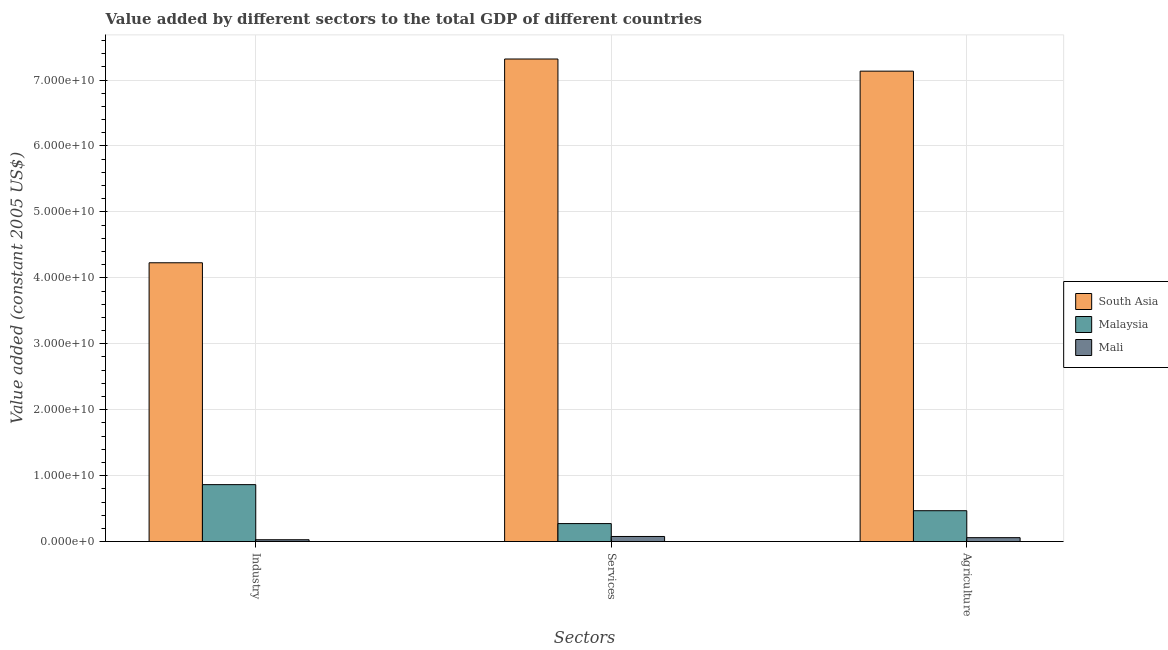How many groups of bars are there?
Your answer should be compact. 3. Are the number of bars per tick equal to the number of legend labels?
Give a very brief answer. Yes. How many bars are there on the 1st tick from the left?
Make the answer very short. 3. How many bars are there on the 1st tick from the right?
Your answer should be compact. 3. What is the label of the 1st group of bars from the left?
Make the answer very short. Industry. What is the value added by agricultural sector in Malaysia?
Offer a very short reply. 4.68e+09. Across all countries, what is the maximum value added by agricultural sector?
Ensure brevity in your answer.  7.13e+1. Across all countries, what is the minimum value added by industrial sector?
Your answer should be very brief. 2.76e+08. In which country was the value added by industrial sector minimum?
Keep it short and to the point. Mali. What is the total value added by services in the graph?
Keep it short and to the point. 7.67e+1. What is the difference between the value added by industrial sector in Mali and that in Malaysia?
Ensure brevity in your answer.  -8.36e+09. What is the difference between the value added by agricultural sector in South Asia and the value added by services in Malaysia?
Offer a terse response. 6.86e+1. What is the average value added by agricultural sector per country?
Give a very brief answer. 2.55e+1. What is the difference between the value added by services and value added by industrial sector in Mali?
Keep it short and to the point. 4.95e+08. In how many countries, is the value added by services greater than 34000000000 US$?
Provide a short and direct response. 1. What is the ratio of the value added by agricultural sector in Mali to that in South Asia?
Make the answer very short. 0.01. Is the value added by industrial sector in Mali less than that in Malaysia?
Your answer should be compact. Yes. What is the difference between the highest and the second highest value added by industrial sector?
Provide a succinct answer. 3.36e+1. What is the difference between the highest and the lowest value added by agricultural sector?
Offer a terse response. 7.08e+1. Is the sum of the value added by services in South Asia and Malaysia greater than the maximum value added by agricultural sector across all countries?
Make the answer very short. Yes. What does the 1st bar from the left in Services represents?
Your answer should be compact. South Asia. Is it the case that in every country, the sum of the value added by industrial sector and value added by services is greater than the value added by agricultural sector?
Provide a short and direct response. Yes. How many bars are there?
Ensure brevity in your answer.  9. Are the values on the major ticks of Y-axis written in scientific E-notation?
Your answer should be compact. Yes. Does the graph contain any zero values?
Give a very brief answer. No. How are the legend labels stacked?
Ensure brevity in your answer.  Vertical. What is the title of the graph?
Keep it short and to the point. Value added by different sectors to the total GDP of different countries. Does "Croatia" appear as one of the legend labels in the graph?
Your answer should be compact. No. What is the label or title of the X-axis?
Your answer should be compact. Sectors. What is the label or title of the Y-axis?
Provide a short and direct response. Value added (constant 2005 US$). What is the Value added (constant 2005 US$) in South Asia in Industry?
Offer a terse response. 4.23e+1. What is the Value added (constant 2005 US$) in Malaysia in Industry?
Offer a terse response. 8.63e+09. What is the Value added (constant 2005 US$) in Mali in Industry?
Your answer should be very brief. 2.76e+08. What is the Value added (constant 2005 US$) in South Asia in Services?
Offer a terse response. 7.32e+1. What is the Value added (constant 2005 US$) of Malaysia in Services?
Make the answer very short. 2.73e+09. What is the Value added (constant 2005 US$) in Mali in Services?
Provide a succinct answer. 7.71e+08. What is the Value added (constant 2005 US$) of South Asia in Agriculture?
Provide a succinct answer. 7.13e+1. What is the Value added (constant 2005 US$) in Malaysia in Agriculture?
Ensure brevity in your answer.  4.68e+09. What is the Value added (constant 2005 US$) of Mali in Agriculture?
Ensure brevity in your answer.  5.90e+08. Across all Sectors, what is the maximum Value added (constant 2005 US$) in South Asia?
Make the answer very short. 7.32e+1. Across all Sectors, what is the maximum Value added (constant 2005 US$) in Malaysia?
Ensure brevity in your answer.  8.63e+09. Across all Sectors, what is the maximum Value added (constant 2005 US$) in Mali?
Keep it short and to the point. 7.71e+08. Across all Sectors, what is the minimum Value added (constant 2005 US$) of South Asia?
Your answer should be very brief. 4.23e+1. Across all Sectors, what is the minimum Value added (constant 2005 US$) of Malaysia?
Your answer should be compact. 2.73e+09. Across all Sectors, what is the minimum Value added (constant 2005 US$) in Mali?
Your answer should be compact. 2.76e+08. What is the total Value added (constant 2005 US$) in South Asia in the graph?
Offer a terse response. 1.87e+11. What is the total Value added (constant 2005 US$) of Malaysia in the graph?
Your response must be concise. 1.60e+1. What is the total Value added (constant 2005 US$) in Mali in the graph?
Offer a very short reply. 1.64e+09. What is the difference between the Value added (constant 2005 US$) in South Asia in Industry and that in Services?
Ensure brevity in your answer.  -3.09e+1. What is the difference between the Value added (constant 2005 US$) in Malaysia in Industry and that in Services?
Ensure brevity in your answer.  5.91e+09. What is the difference between the Value added (constant 2005 US$) of Mali in Industry and that in Services?
Keep it short and to the point. -4.95e+08. What is the difference between the Value added (constant 2005 US$) of South Asia in Industry and that in Agriculture?
Provide a short and direct response. -2.91e+1. What is the difference between the Value added (constant 2005 US$) in Malaysia in Industry and that in Agriculture?
Make the answer very short. 3.96e+09. What is the difference between the Value added (constant 2005 US$) of Mali in Industry and that in Agriculture?
Offer a very short reply. -3.15e+08. What is the difference between the Value added (constant 2005 US$) in South Asia in Services and that in Agriculture?
Offer a terse response. 1.84e+09. What is the difference between the Value added (constant 2005 US$) of Malaysia in Services and that in Agriculture?
Ensure brevity in your answer.  -1.95e+09. What is the difference between the Value added (constant 2005 US$) of Mali in Services and that in Agriculture?
Give a very brief answer. 1.80e+08. What is the difference between the Value added (constant 2005 US$) of South Asia in Industry and the Value added (constant 2005 US$) of Malaysia in Services?
Your response must be concise. 3.96e+1. What is the difference between the Value added (constant 2005 US$) in South Asia in Industry and the Value added (constant 2005 US$) in Mali in Services?
Your answer should be compact. 4.15e+1. What is the difference between the Value added (constant 2005 US$) of Malaysia in Industry and the Value added (constant 2005 US$) of Mali in Services?
Make the answer very short. 7.86e+09. What is the difference between the Value added (constant 2005 US$) of South Asia in Industry and the Value added (constant 2005 US$) of Malaysia in Agriculture?
Provide a short and direct response. 3.76e+1. What is the difference between the Value added (constant 2005 US$) of South Asia in Industry and the Value added (constant 2005 US$) of Mali in Agriculture?
Your answer should be very brief. 4.17e+1. What is the difference between the Value added (constant 2005 US$) in Malaysia in Industry and the Value added (constant 2005 US$) in Mali in Agriculture?
Ensure brevity in your answer.  8.04e+09. What is the difference between the Value added (constant 2005 US$) in South Asia in Services and the Value added (constant 2005 US$) in Malaysia in Agriculture?
Keep it short and to the point. 6.85e+1. What is the difference between the Value added (constant 2005 US$) in South Asia in Services and the Value added (constant 2005 US$) in Mali in Agriculture?
Provide a succinct answer. 7.26e+1. What is the difference between the Value added (constant 2005 US$) in Malaysia in Services and the Value added (constant 2005 US$) in Mali in Agriculture?
Your response must be concise. 2.14e+09. What is the average Value added (constant 2005 US$) in South Asia per Sectors?
Make the answer very short. 6.23e+1. What is the average Value added (constant 2005 US$) of Malaysia per Sectors?
Provide a short and direct response. 5.35e+09. What is the average Value added (constant 2005 US$) in Mali per Sectors?
Ensure brevity in your answer.  5.46e+08. What is the difference between the Value added (constant 2005 US$) of South Asia and Value added (constant 2005 US$) of Malaysia in Industry?
Ensure brevity in your answer.  3.36e+1. What is the difference between the Value added (constant 2005 US$) in South Asia and Value added (constant 2005 US$) in Mali in Industry?
Keep it short and to the point. 4.20e+1. What is the difference between the Value added (constant 2005 US$) of Malaysia and Value added (constant 2005 US$) of Mali in Industry?
Provide a short and direct response. 8.36e+09. What is the difference between the Value added (constant 2005 US$) in South Asia and Value added (constant 2005 US$) in Malaysia in Services?
Provide a succinct answer. 7.05e+1. What is the difference between the Value added (constant 2005 US$) in South Asia and Value added (constant 2005 US$) in Mali in Services?
Give a very brief answer. 7.24e+1. What is the difference between the Value added (constant 2005 US$) in Malaysia and Value added (constant 2005 US$) in Mali in Services?
Provide a short and direct response. 1.95e+09. What is the difference between the Value added (constant 2005 US$) of South Asia and Value added (constant 2005 US$) of Malaysia in Agriculture?
Your answer should be compact. 6.67e+1. What is the difference between the Value added (constant 2005 US$) in South Asia and Value added (constant 2005 US$) in Mali in Agriculture?
Your answer should be very brief. 7.08e+1. What is the difference between the Value added (constant 2005 US$) of Malaysia and Value added (constant 2005 US$) of Mali in Agriculture?
Your answer should be very brief. 4.09e+09. What is the ratio of the Value added (constant 2005 US$) of South Asia in Industry to that in Services?
Provide a succinct answer. 0.58. What is the ratio of the Value added (constant 2005 US$) of Malaysia in Industry to that in Services?
Ensure brevity in your answer.  3.17. What is the ratio of the Value added (constant 2005 US$) in Mali in Industry to that in Services?
Keep it short and to the point. 0.36. What is the ratio of the Value added (constant 2005 US$) of South Asia in Industry to that in Agriculture?
Provide a short and direct response. 0.59. What is the ratio of the Value added (constant 2005 US$) of Malaysia in Industry to that in Agriculture?
Provide a short and direct response. 1.85. What is the ratio of the Value added (constant 2005 US$) of Mali in Industry to that in Agriculture?
Your response must be concise. 0.47. What is the ratio of the Value added (constant 2005 US$) of South Asia in Services to that in Agriculture?
Your response must be concise. 1.03. What is the ratio of the Value added (constant 2005 US$) of Malaysia in Services to that in Agriculture?
Your answer should be compact. 0.58. What is the ratio of the Value added (constant 2005 US$) in Mali in Services to that in Agriculture?
Give a very brief answer. 1.31. What is the difference between the highest and the second highest Value added (constant 2005 US$) of South Asia?
Your answer should be compact. 1.84e+09. What is the difference between the highest and the second highest Value added (constant 2005 US$) in Malaysia?
Ensure brevity in your answer.  3.96e+09. What is the difference between the highest and the second highest Value added (constant 2005 US$) of Mali?
Provide a short and direct response. 1.80e+08. What is the difference between the highest and the lowest Value added (constant 2005 US$) of South Asia?
Offer a very short reply. 3.09e+1. What is the difference between the highest and the lowest Value added (constant 2005 US$) of Malaysia?
Ensure brevity in your answer.  5.91e+09. What is the difference between the highest and the lowest Value added (constant 2005 US$) of Mali?
Ensure brevity in your answer.  4.95e+08. 